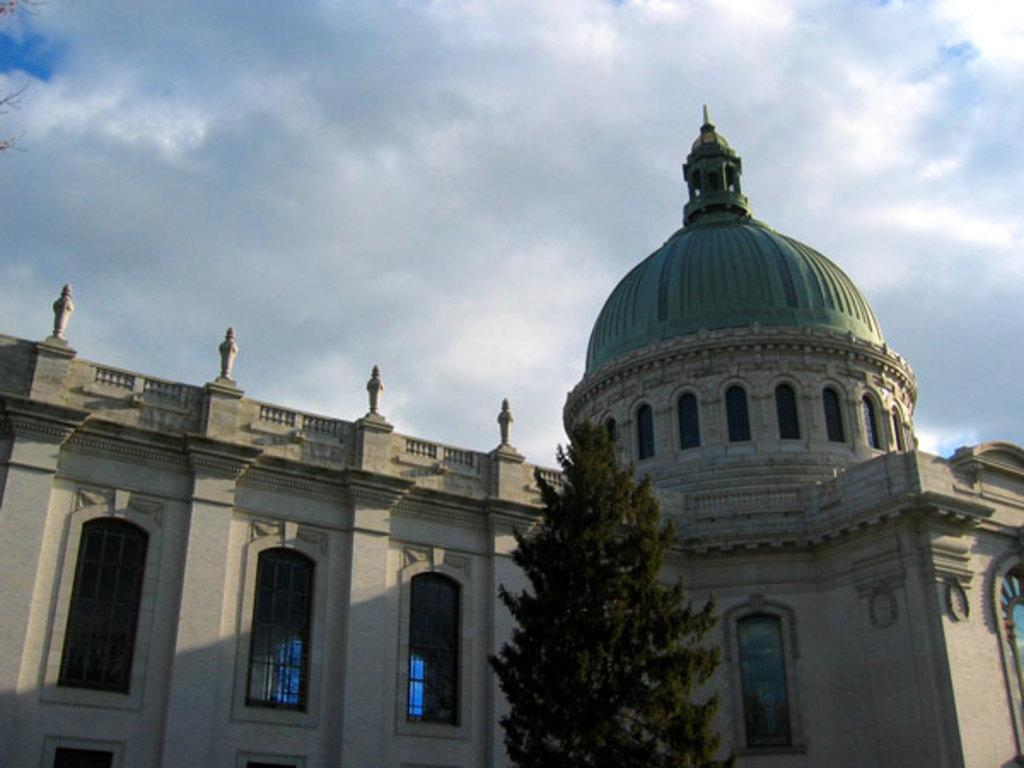What type of building is partially visible in the image? There is a part of a palace building in the image. What feature can be seen on the palace building? The palace building has glass windows. What natural element is located near the palace building? There is a tree near the palace building. What is visible behind the palace building? The sky is visible behind the palace building. What can be observed in the sky? Clouds are present in the sky. Where is the mask located in the image? There is no mask present in the image. What type of base is supporting the palace building in the image? The image does not show a base supporting the palace building; it only shows a part of the building. 